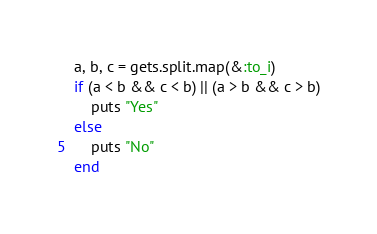Convert code to text. <code><loc_0><loc_0><loc_500><loc_500><_Ruby_>a, b, c = gets.split.map(&:to_i)
if (a < b && c < b) || (a > b && c > b)
    puts "Yes"
else
    puts "No"
end</code> 